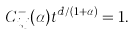<formula> <loc_0><loc_0><loc_500><loc_500>C _ { i , j } ^ { - } ( \alpha ) t ^ { d / ( 1 + \alpha ) } = 1 .</formula> 